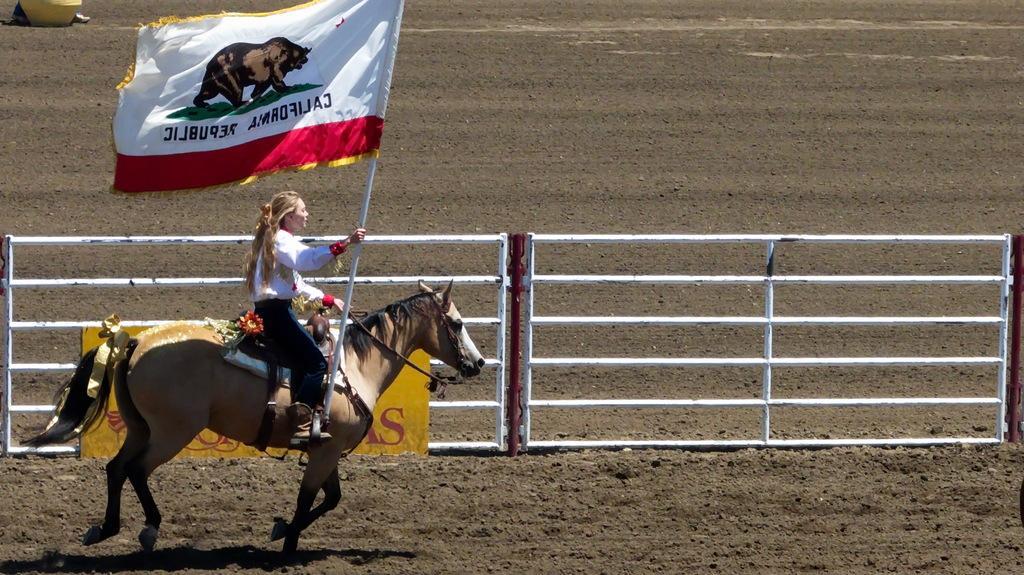In one or two sentences, can you explain what this image depicts? In this image we can see a woman wearing white dress is holding a flag on which we can see an animal and some text, is sitting on the horse and riding on the ground. In the background, we can see the fence and something which is in yellow color. 